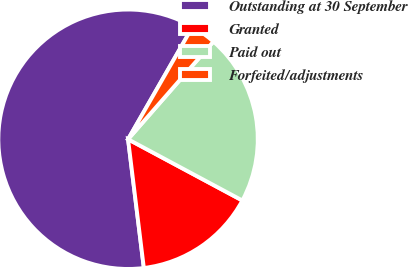<chart> <loc_0><loc_0><loc_500><loc_500><pie_chart><fcel>Outstanding at 30 September<fcel>Granted<fcel>Paid out<fcel>Forfeited/adjustments<nl><fcel>60.24%<fcel>15.23%<fcel>21.4%<fcel>3.14%<nl></chart> 